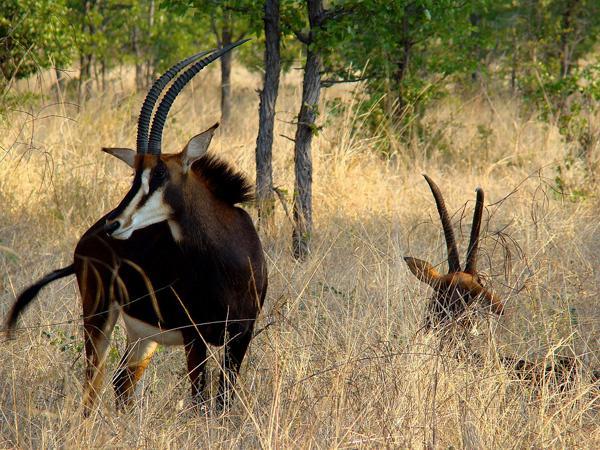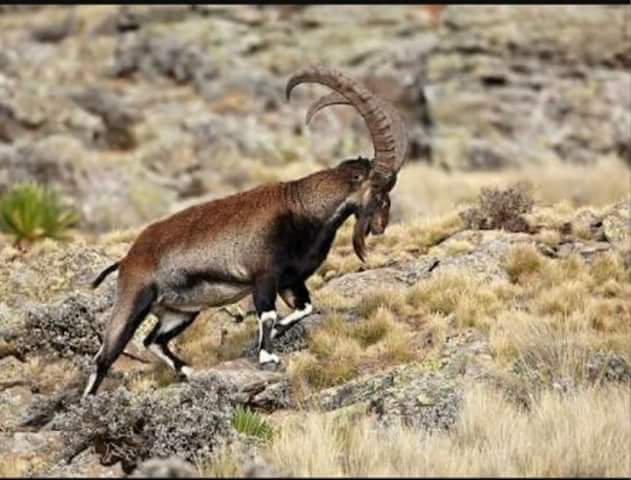The first image is the image on the left, the second image is the image on the right. Assess this claim about the two images: "A herd of elephants mills about behind another type of animal.". Correct or not? Answer yes or no. No. 